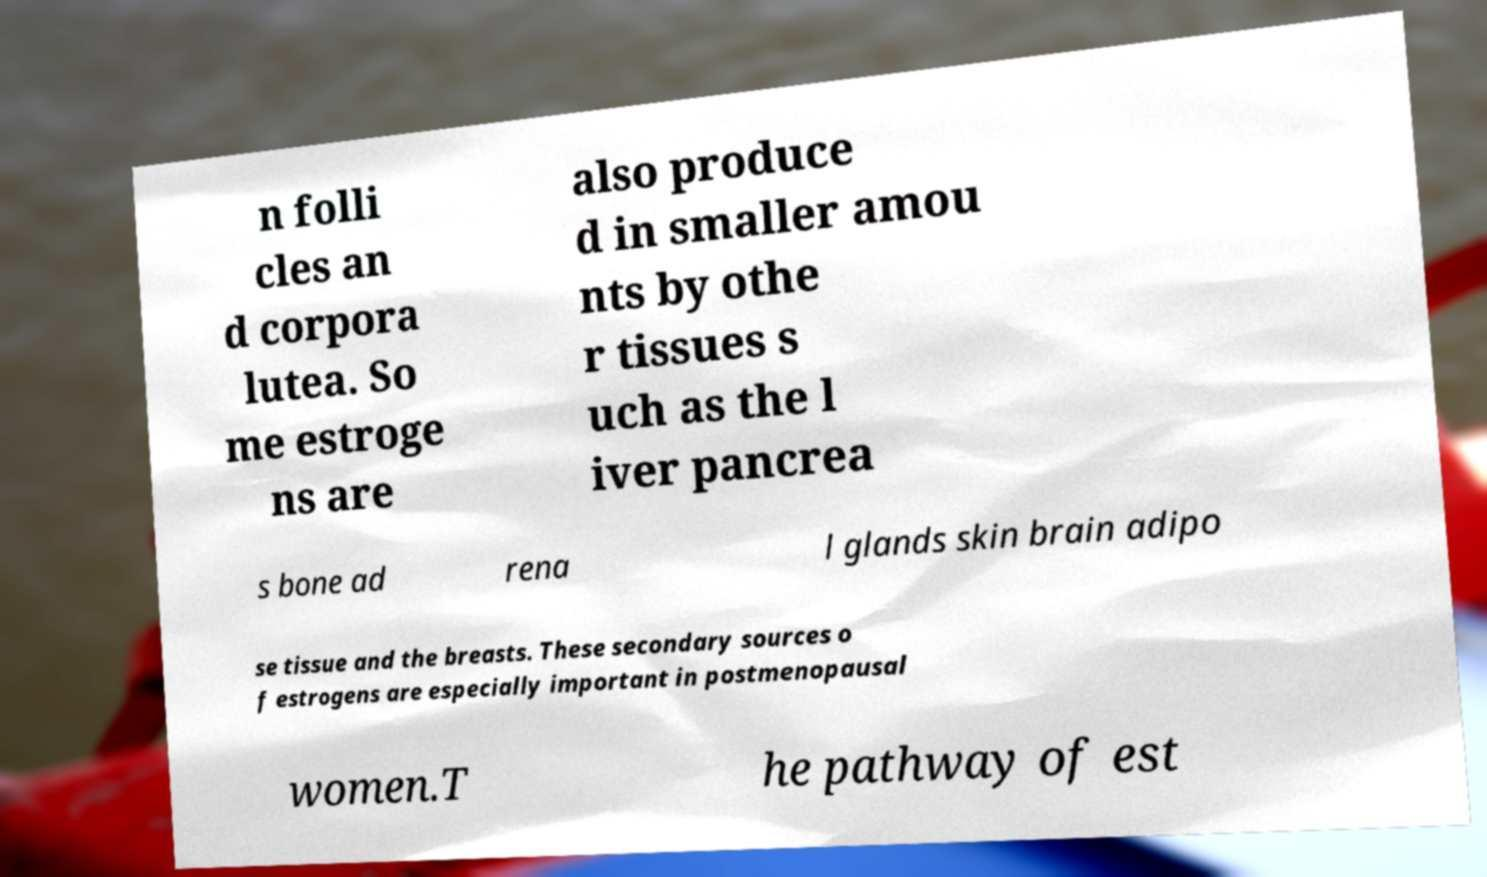Could you extract and type out the text from this image? n folli cles an d corpora lutea. So me estroge ns are also produce d in smaller amou nts by othe r tissues s uch as the l iver pancrea s bone ad rena l glands skin brain adipo se tissue and the breasts. These secondary sources o f estrogens are especially important in postmenopausal women.T he pathway of est 